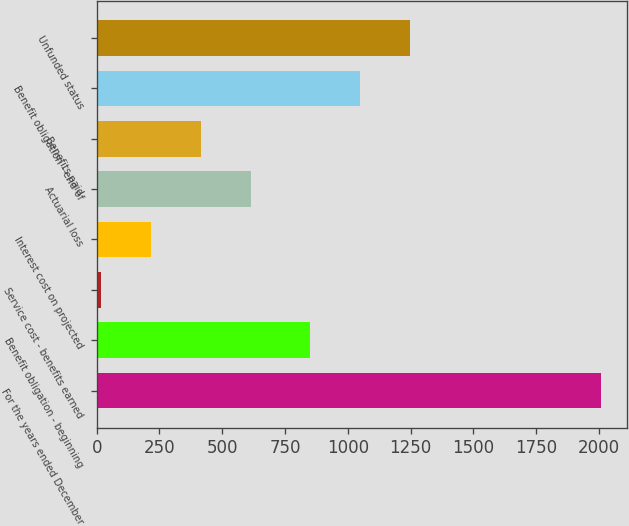Convert chart to OTSL. <chart><loc_0><loc_0><loc_500><loc_500><bar_chart><fcel>For the years ended December<fcel>Benefit obligation - beginning<fcel>Service cost - benefits earned<fcel>Interest cost on projected<fcel>Actuarial loss<fcel>Benefits paid<fcel>Benefit obligation - end of<fcel>Unfunded status<nl><fcel>2010<fcel>848<fcel>18<fcel>217.2<fcel>615.6<fcel>416.4<fcel>1047.2<fcel>1246.4<nl></chart> 